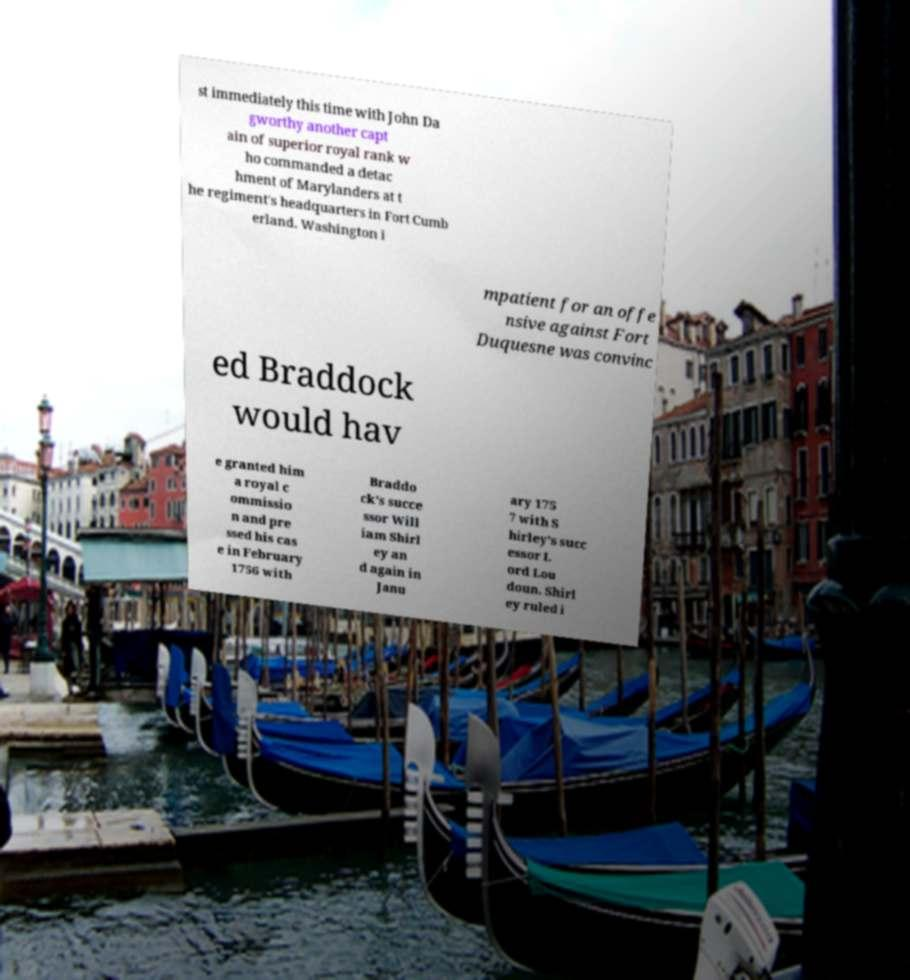What messages or text are displayed in this image? I need them in a readable, typed format. st immediately this time with John Da gworthy another capt ain of superior royal rank w ho commanded a detac hment of Marylanders at t he regiment's headquarters in Fort Cumb erland. Washington i mpatient for an offe nsive against Fort Duquesne was convinc ed Braddock would hav e granted him a royal c ommissio n and pre ssed his cas e in February 1756 with Braddo ck's succe ssor Will iam Shirl ey an d again in Janu ary 175 7 with S hirley's succ essor L ord Lou doun. Shirl ey ruled i 